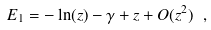<formula> <loc_0><loc_0><loc_500><loc_500>E _ { 1 } = - \ln ( z ) - \gamma + z + O ( z ^ { 2 } ) \ ,</formula> 